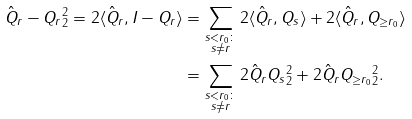Convert formula to latex. <formula><loc_0><loc_0><loc_500><loc_500>\| \hat { Q } _ { r } - Q _ { r } \| _ { 2 } ^ { 2 } = 2 \langle \hat { Q } _ { r } , I - Q _ { r } \rangle & = \sum _ { \substack { s < r _ { 0 } \colon \\ s \neq r } } 2 \langle \hat { Q } _ { r } , Q _ { s } \rangle + 2 \langle \hat { Q } _ { r } , Q _ { \geq r _ { 0 } } \rangle \\ & = \sum _ { \substack { s < r _ { 0 } \colon \\ s \neq r } } 2 \| \hat { Q } _ { r } Q _ { s } \| _ { 2 } ^ { 2 } + 2 \| \hat { Q } _ { r } Q _ { \geq r _ { 0 } } \| _ { 2 } ^ { 2 } .</formula> 